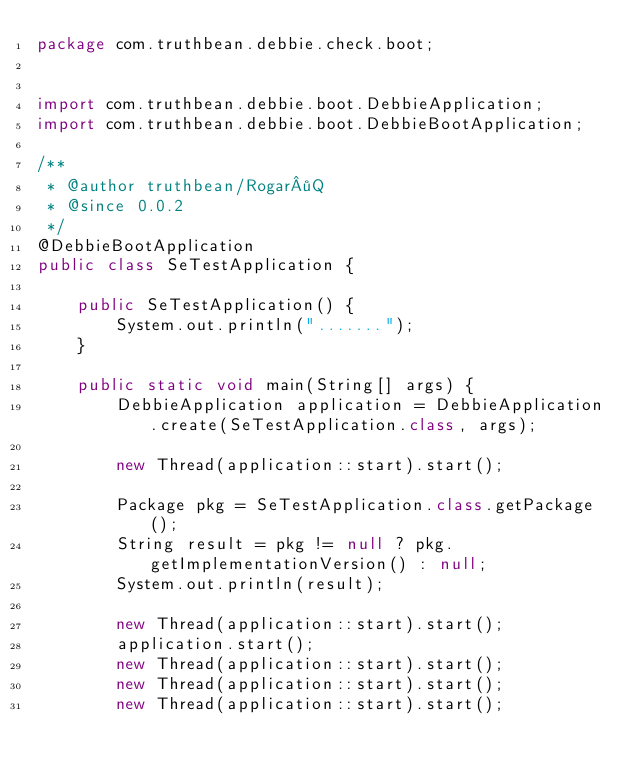Convert code to text. <code><loc_0><loc_0><loc_500><loc_500><_Java_>package com.truthbean.debbie.check.boot;


import com.truthbean.debbie.boot.DebbieApplication;
import com.truthbean.debbie.boot.DebbieBootApplication;

/**
 * @author truthbean/Rogar·Q
 * @since 0.0.2
 */
@DebbieBootApplication
public class SeTestApplication {

    public SeTestApplication() {
        System.out.println(".......");
    }

    public static void main(String[] args) {
        DebbieApplication application = DebbieApplication.create(SeTestApplication.class, args);

        new Thread(application::start).start();

        Package pkg = SeTestApplication.class.getPackage();
        String result = pkg != null ? pkg.getImplementationVersion() : null;
        System.out.println(result);

        new Thread(application::start).start();
        application.start();
        new Thread(application::start).start();
        new Thread(application::start).start();
        new Thread(application::start).start();
</code> 